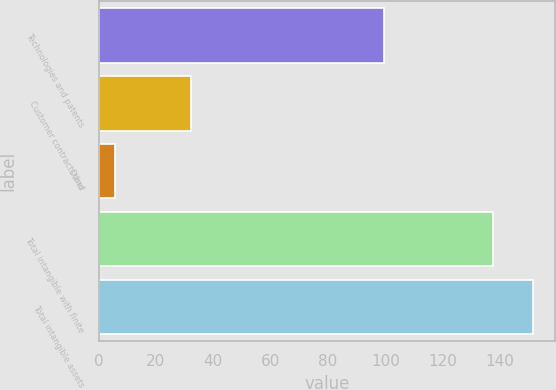<chart> <loc_0><loc_0><loc_500><loc_500><bar_chart><fcel>Technologies and patents<fcel>Customer contracts and<fcel>Other<fcel>Total intangible with finite<fcel>Total intangible assets<nl><fcel>99.6<fcel>32.3<fcel>5.6<fcel>137.5<fcel>151.57<nl></chart> 